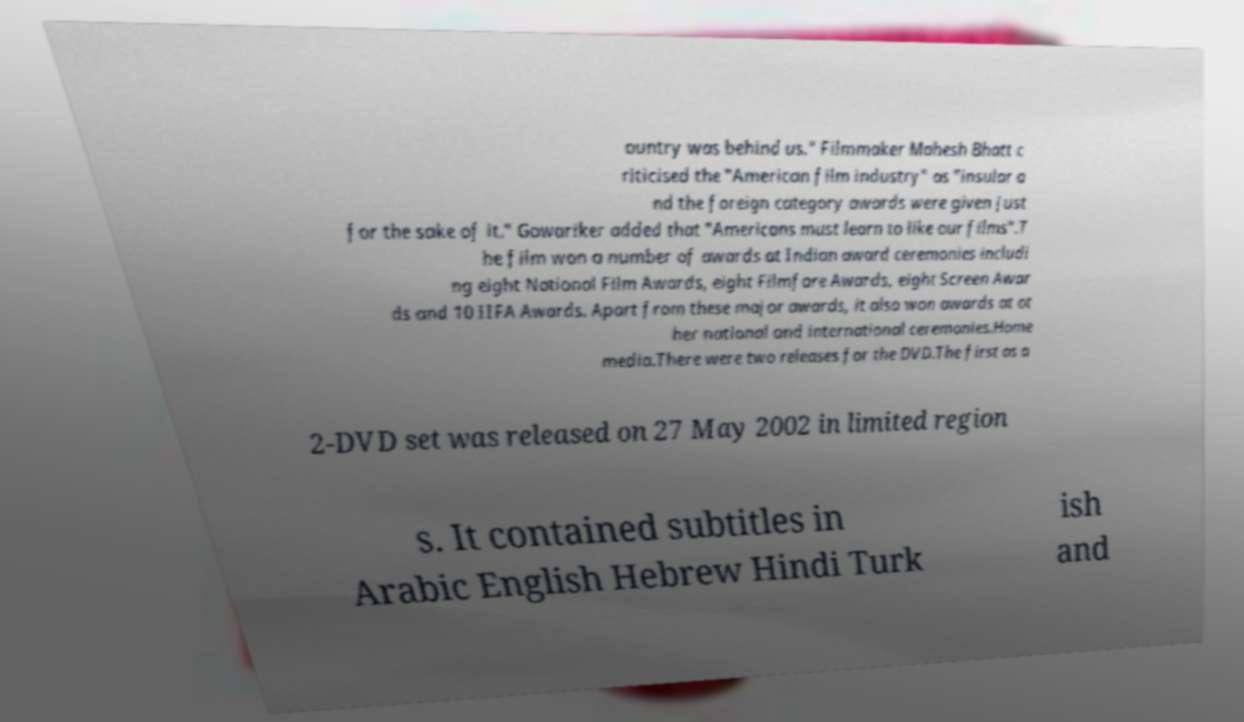Please read and relay the text visible in this image. What does it say? ountry was behind us." Filmmaker Mahesh Bhatt c riticised the "American film industry" as "insular a nd the foreign category awards were given just for the sake of it." Gowariker added that "Americans must learn to like our films".T he film won a number of awards at Indian award ceremonies includi ng eight National Film Awards, eight Filmfare Awards, eight Screen Awar ds and 10 IIFA Awards. Apart from these major awards, it also won awards at ot her national and international ceremonies.Home media.There were two releases for the DVD.The first as a 2-DVD set was released on 27 May 2002 in limited region s. It contained subtitles in Arabic English Hebrew Hindi Turk ish and 